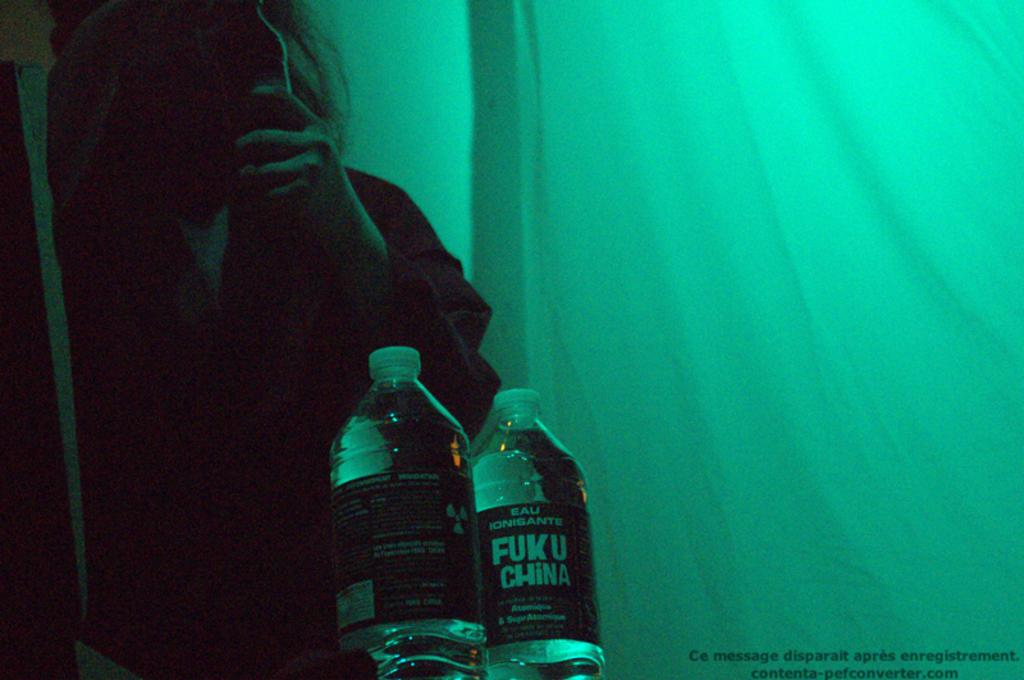<image>
Summarize the visual content of the image. a water bottle with a label on it that says 'fuku china' 